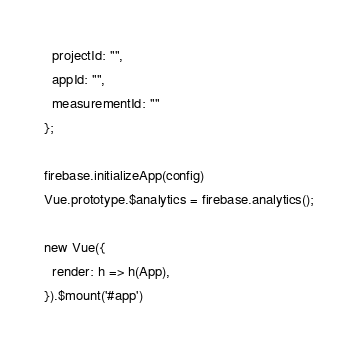<code> <loc_0><loc_0><loc_500><loc_500><_JavaScript_>  projectId: "",
  appId: "",
  measurementId: ""
};

firebase.initializeApp(config)
Vue.prototype.$analytics = firebase.analytics();

new Vue({
  render: h => h(App),
}).$mount('#app')
</code> 